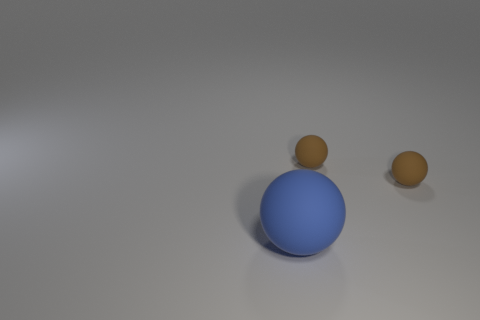How many small matte things are the same shape as the big blue thing? 2 